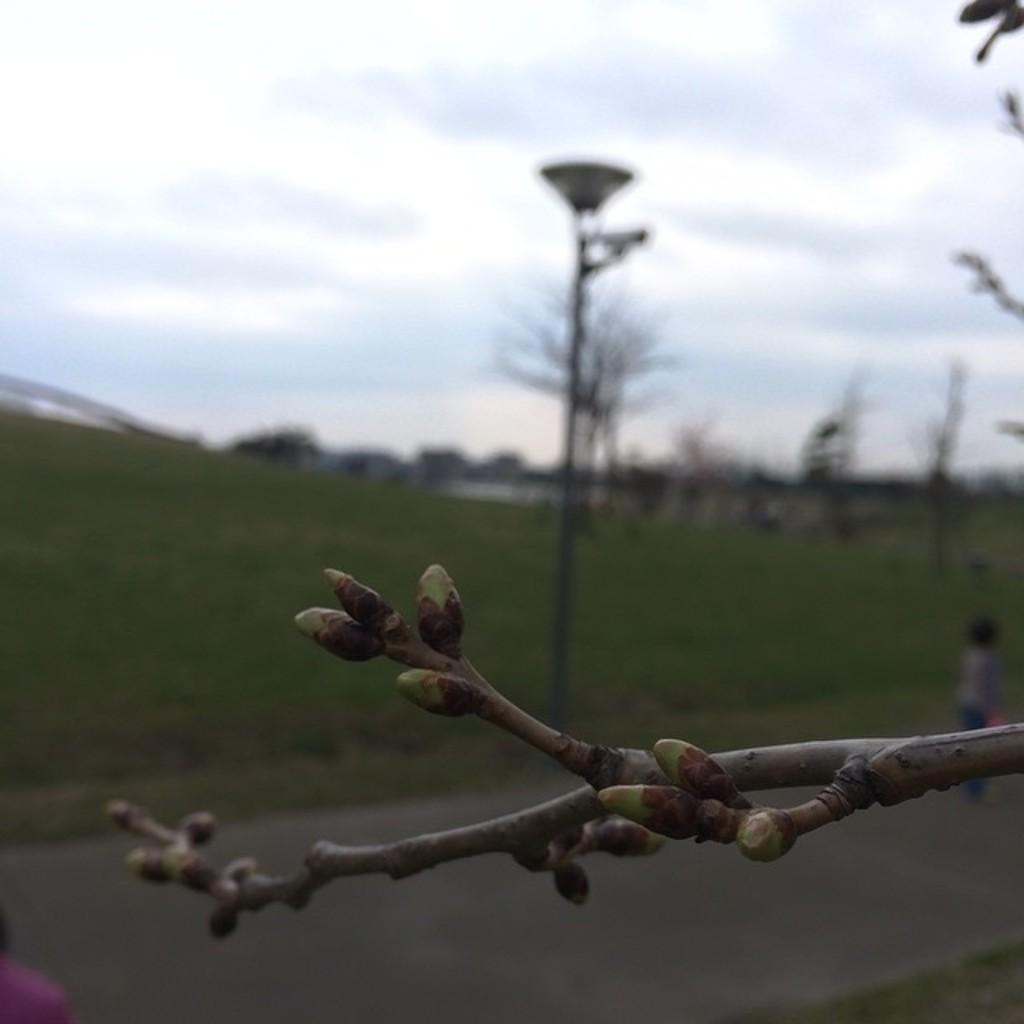Could you give a brief overview of what you see in this image? This image consists of a plant stem. In the background, there are trees and poles. At the bottom, there is road. At the top, there are clouds in the sky. 